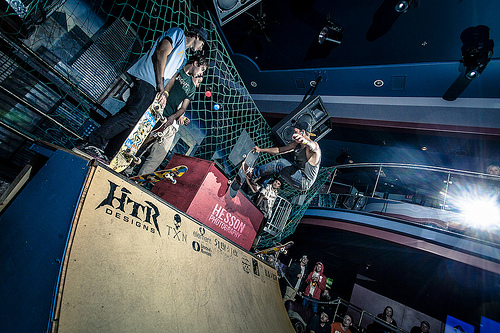<image>
Is the ramp behind the wall? No. The ramp is not behind the wall. From this viewpoint, the ramp appears to be positioned elsewhere in the scene. 